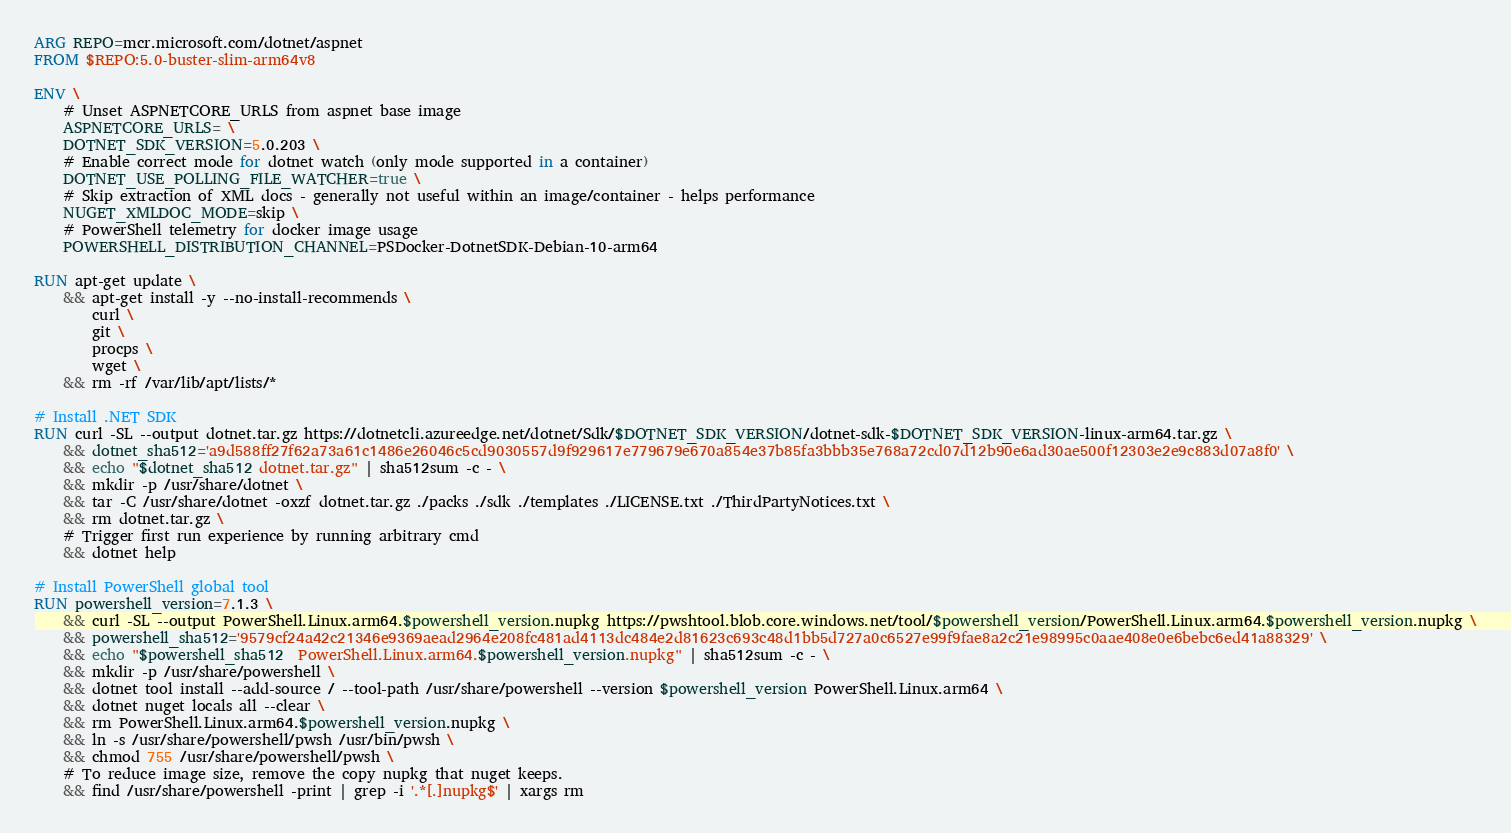Convert code to text. <code><loc_0><loc_0><loc_500><loc_500><_Dockerfile_>ARG REPO=mcr.microsoft.com/dotnet/aspnet
FROM $REPO:5.0-buster-slim-arm64v8

ENV \
    # Unset ASPNETCORE_URLS from aspnet base image
    ASPNETCORE_URLS= \
    DOTNET_SDK_VERSION=5.0.203 \
    # Enable correct mode for dotnet watch (only mode supported in a container)
    DOTNET_USE_POLLING_FILE_WATCHER=true \
    # Skip extraction of XML docs - generally not useful within an image/container - helps performance
    NUGET_XMLDOC_MODE=skip \
    # PowerShell telemetry for docker image usage
    POWERSHELL_DISTRIBUTION_CHANNEL=PSDocker-DotnetSDK-Debian-10-arm64

RUN apt-get update \
    && apt-get install -y --no-install-recommends \
        curl \
        git \
        procps \
        wget \
    && rm -rf /var/lib/apt/lists/*

# Install .NET SDK
RUN curl -SL --output dotnet.tar.gz https://dotnetcli.azureedge.net/dotnet/Sdk/$DOTNET_SDK_VERSION/dotnet-sdk-$DOTNET_SDK_VERSION-linux-arm64.tar.gz \
    && dotnet_sha512='a9d588ff27f62a73a61c1486e26046c5cd9030557d9f929617e779679e670a854e37b85fa3bbb35e768a72cd07d12b90e6ad30ae500f12303e2e9c883d07a8f0' \
    && echo "$dotnet_sha512 dotnet.tar.gz" | sha512sum -c - \
    && mkdir -p /usr/share/dotnet \
    && tar -C /usr/share/dotnet -oxzf dotnet.tar.gz ./packs ./sdk ./templates ./LICENSE.txt ./ThirdPartyNotices.txt \
    && rm dotnet.tar.gz \
    # Trigger first run experience by running arbitrary cmd
    && dotnet help

# Install PowerShell global tool
RUN powershell_version=7.1.3 \
    && curl -SL --output PowerShell.Linux.arm64.$powershell_version.nupkg https://pwshtool.blob.core.windows.net/tool/$powershell_version/PowerShell.Linux.arm64.$powershell_version.nupkg \
    && powershell_sha512='9579cf24a42c21346e9369aead2964e208fc481ad4113dc484e2d81623c693c48d1bb5d727a0c6527e99f9fae8a2c21e98995c0aae408e0e6bebc6ed41a88329' \
    && echo "$powershell_sha512  PowerShell.Linux.arm64.$powershell_version.nupkg" | sha512sum -c - \
    && mkdir -p /usr/share/powershell \
    && dotnet tool install --add-source / --tool-path /usr/share/powershell --version $powershell_version PowerShell.Linux.arm64 \
    && dotnet nuget locals all --clear \
    && rm PowerShell.Linux.arm64.$powershell_version.nupkg \
    && ln -s /usr/share/powershell/pwsh /usr/bin/pwsh \
    && chmod 755 /usr/share/powershell/pwsh \
    # To reduce image size, remove the copy nupkg that nuget keeps.
    && find /usr/share/powershell -print | grep -i '.*[.]nupkg$' | xargs rm
</code> 